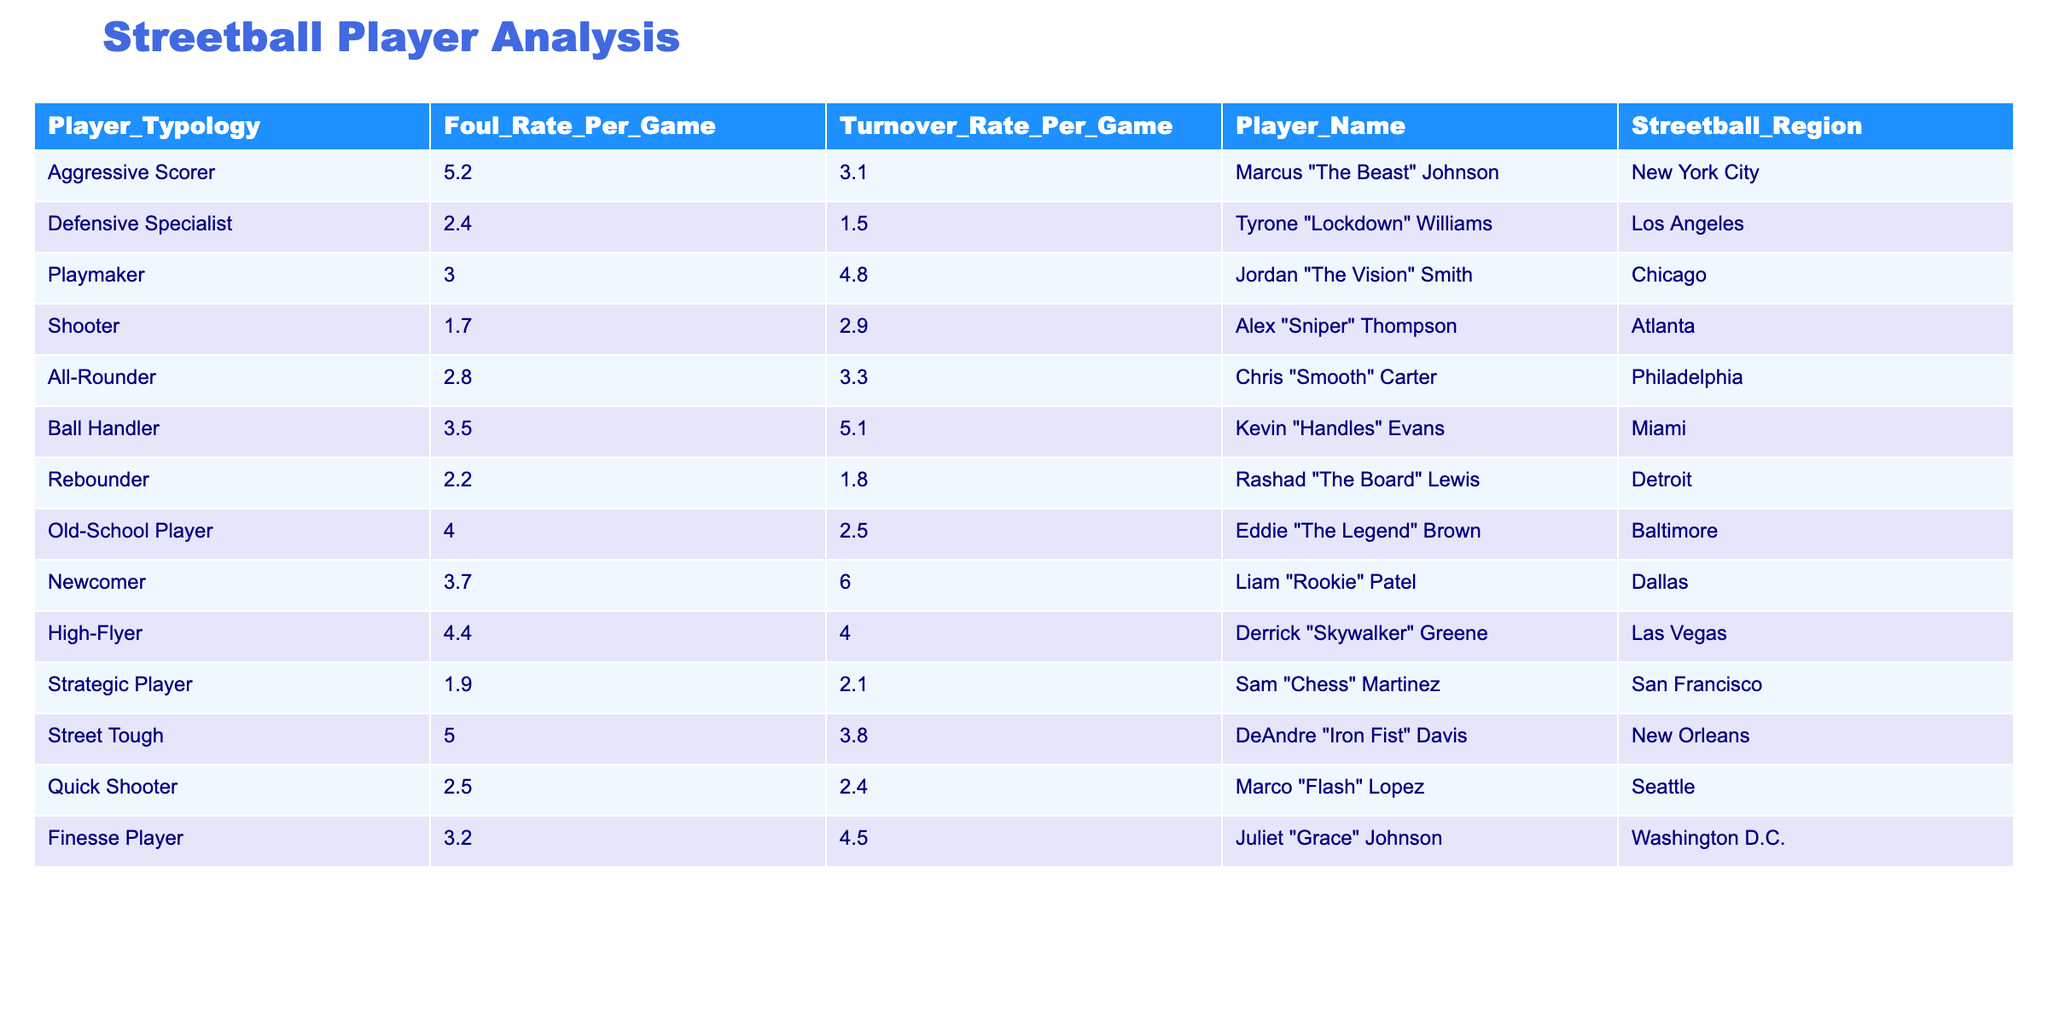What is the foul rate per game for Marcus "The Beast" Johnson? The table lists Marcus "The Beast" Johnson under the player typology of Aggressive Scorer, with a foul rate per game of 5.2.
Answer: 5.2 Which player type has the highest turnover rate per game? By examining the turnover rates in the table, the Newcomer player type, represented by Liam "Rookie" Patel, has the highest turnover rate at 6.0.
Answer: Newcomer What is the average foul rate for all players categorized as Defensive Specialists? The only player categorized under Defensive Specialist is Tyrone "Lockdown" Williams, who has a foul rate of 2.4. Thus, the average foul rate is 2.4.
Answer: 2.4 Which player has the lowest turnover rate per game? Looking through the table, Rashad "The Board" Lewis, categorized as a Rebounder, has the lowest turnover rate per game at 1.8.
Answer: Rashad "The Board" Lewis Is there any player type that has both a foul rate and a turnover rate higher than 5.0? The data shows that the Newcomer player type has a foul rate of 3.7 and a turnover rate of 6.0. The Aggressive Scorer type has a foul rate of 5.2 and a turnover rate of 3.1. Therefore, no player type has both rates above 5.0.
Answer: No What is the total foul rate for Aggressive Scorer and Ball Handler types combined? The foul rates for Aggressive Scorer (5.2) and Ball Handler (3.5) are summed: 5.2 + 3.5 = 8.7.
Answer: 8.7 If we compare the average foul rates of All-Rounders and Strategic Players, which one has a higher rate? The average foul rate for the All-Rounder (2.8) is greater than the average for the Strategic Player (1.9). Comparing the values shows that All-Rounders have a higher rate.
Answer: All-Rounder How many players have a foul rate that is 4.0 or higher? The players with a foul rate of 4.0 or above are Marcus "The Beast" Johnson (5.2), Old-School Player (4.0), High-Flyer (4.4), and Street Tough (5.0). This sums to four players.
Answer: 4 Find the player with the highest foul rate and also identify their region. The player with the highest foul rate is Marcus "The Beast" Johnson at 5.2, who is from New York City.
Answer: Marcus "The Beast" Johnson, New York City What is the difference in turnover rates between Newcomer and Shooter types? The turnover rate for the Newcomer is 6.0, while the Shooter has a rate of 2.9. The difference is calculated as 6.0 - 2.9 = 3.1.
Answer: 3.1 